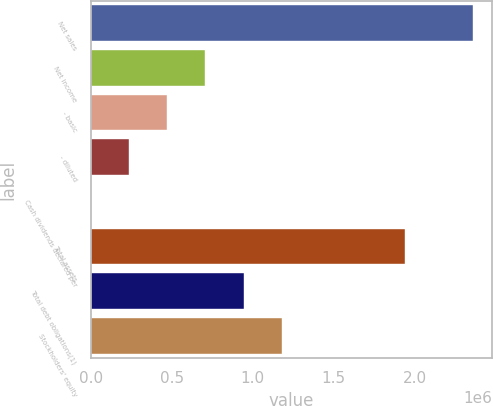Convert chart to OTSL. <chart><loc_0><loc_0><loc_500><loc_500><bar_chart><fcel>Net sales<fcel>Net income<fcel>- basic<fcel>- diluted<fcel>Cash dividends declared per<fcel>Total assets<fcel>Total debt obligations(1)<fcel>Stockholders' equity<nl><fcel>2.36049e+06<fcel>708149<fcel>472100<fcel>236050<fcel>1.2<fcel>1.93974e+06<fcel>944198<fcel>1.18025e+06<nl></chart> 